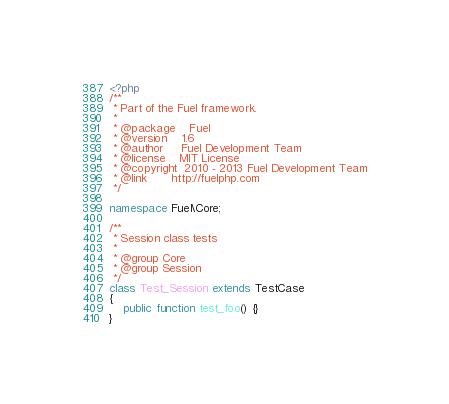Convert code to text. <code><loc_0><loc_0><loc_500><loc_500><_PHP_><?php
/**
 * Part of the Fuel framework.
 *
 * @package    Fuel
 * @version    1.6
 * @author     Fuel Development Team
 * @license    MIT License
 * @copyright  2010 - 2013 Fuel Development Team
 * @link       http://fuelphp.com
 */

namespace Fuel\Core;

/**
 * Session class tests
 *
 * @group Core
 * @group Session
 */
class Test_Session extends TestCase
{
 	public function test_foo() {}
}
</code> 